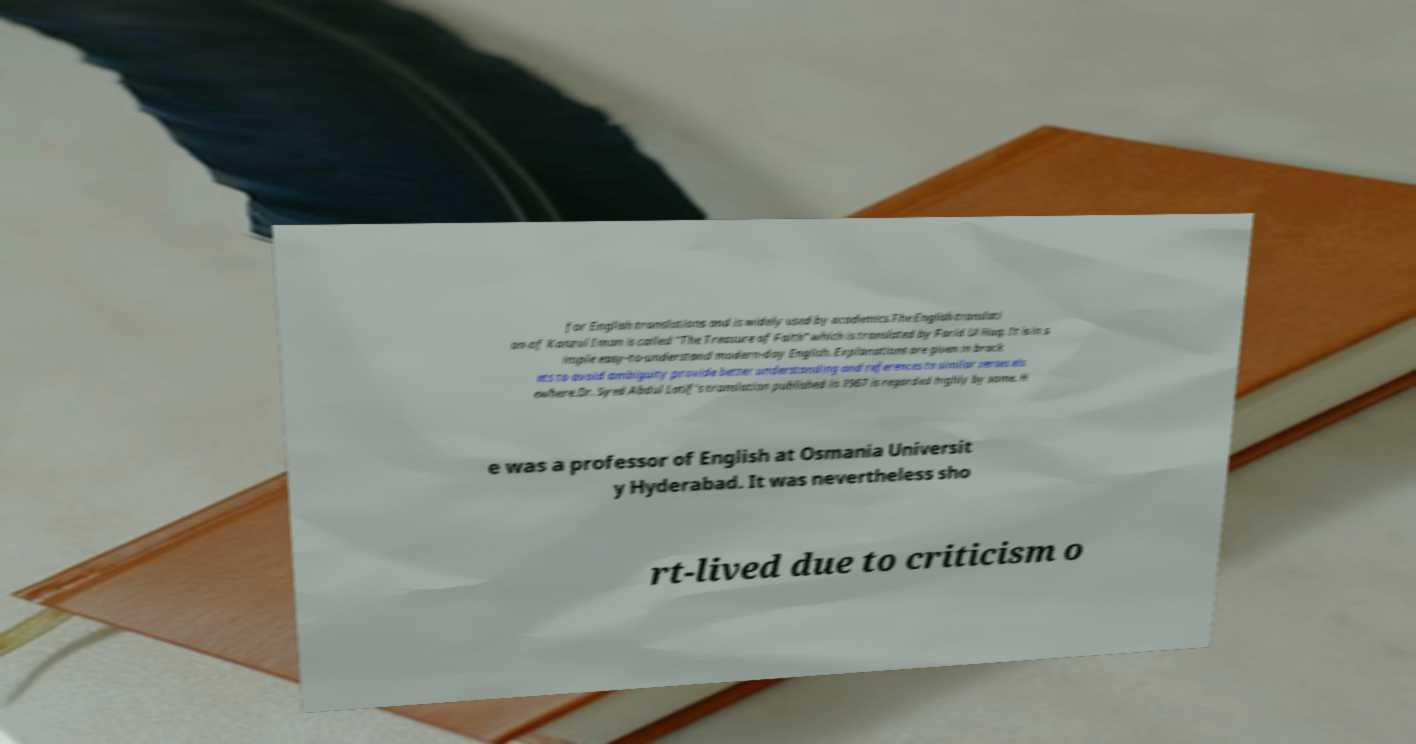Can you read and provide the text displayed in the image?This photo seems to have some interesting text. Can you extract and type it out for me? for English translations and is widely used by academics.The English translati on of Kanzul Iman is called "The Treasure of Faith" which is translated by Farid Ul Haq. It is in s imple easy-to-understand modern-day English. Explanations are given in brack ets to avoid ambiguity provide better understanding and references to similar verses els ewhere.Dr. Syed Abdul Latif's translation published in 1967 is regarded highly by some. H e was a professor of English at Osmania Universit y Hyderabad. It was nevertheless sho rt-lived due to criticism o 